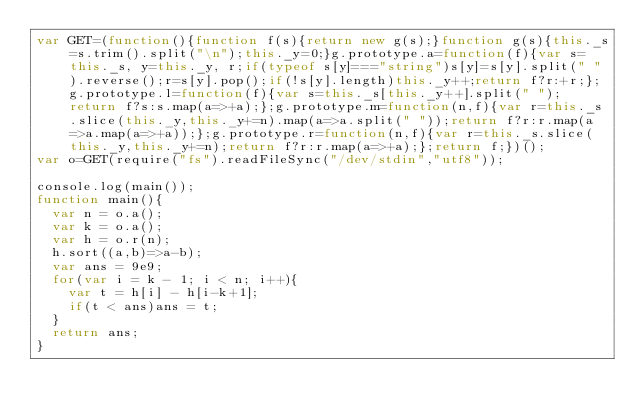<code> <loc_0><loc_0><loc_500><loc_500><_JavaScript_>var GET=(function(){function f(s){return new g(s);}function g(s){this._s=s.trim().split("\n");this._y=0;}g.prototype.a=function(f){var s=this._s, y=this._y, r;if(typeof s[y]==="string")s[y]=s[y].split(" ").reverse();r=s[y].pop();if(!s[y].length)this._y++;return f?r:+r;};g.prototype.l=function(f){var s=this._s[this._y++].split(" ");return f?s:s.map(a=>+a);};g.prototype.m=function(n,f){var r=this._s.slice(this._y,this._y+=n).map(a=>a.split(" "));return f?r:r.map(a=>a.map(a=>+a));};g.prototype.r=function(n,f){var r=this._s.slice(this._y,this._y+=n);return f?r:r.map(a=>+a);};return f;})();
var o=GET(require("fs").readFileSync("/dev/stdin","utf8"));

console.log(main());
function main(){
  var n = o.a();
  var k = o.a();
  var h = o.r(n);
  h.sort((a,b)=>a-b);
  var ans = 9e9;
  for(var i = k - 1; i < n; i++){
    var t = h[i] - h[i-k+1];
    if(t < ans)ans = t;
  }
  return ans;
}</code> 